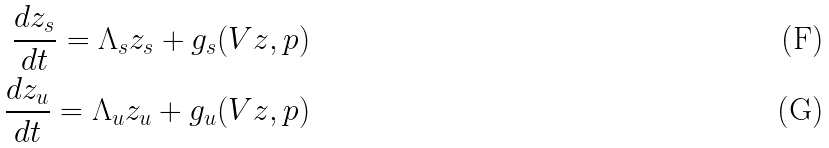<formula> <loc_0><loc_0><loc_500><loc_500>\frac { d z _ { s } } { d t } = \Lambda _ { s } z _ { s } + g _ { s } ( V z , p ) \\ \frac { d z _ { u } } { d t } = \Lambda _ { u } z _ { u } + g _ { u } ( V z , p )</formula> 